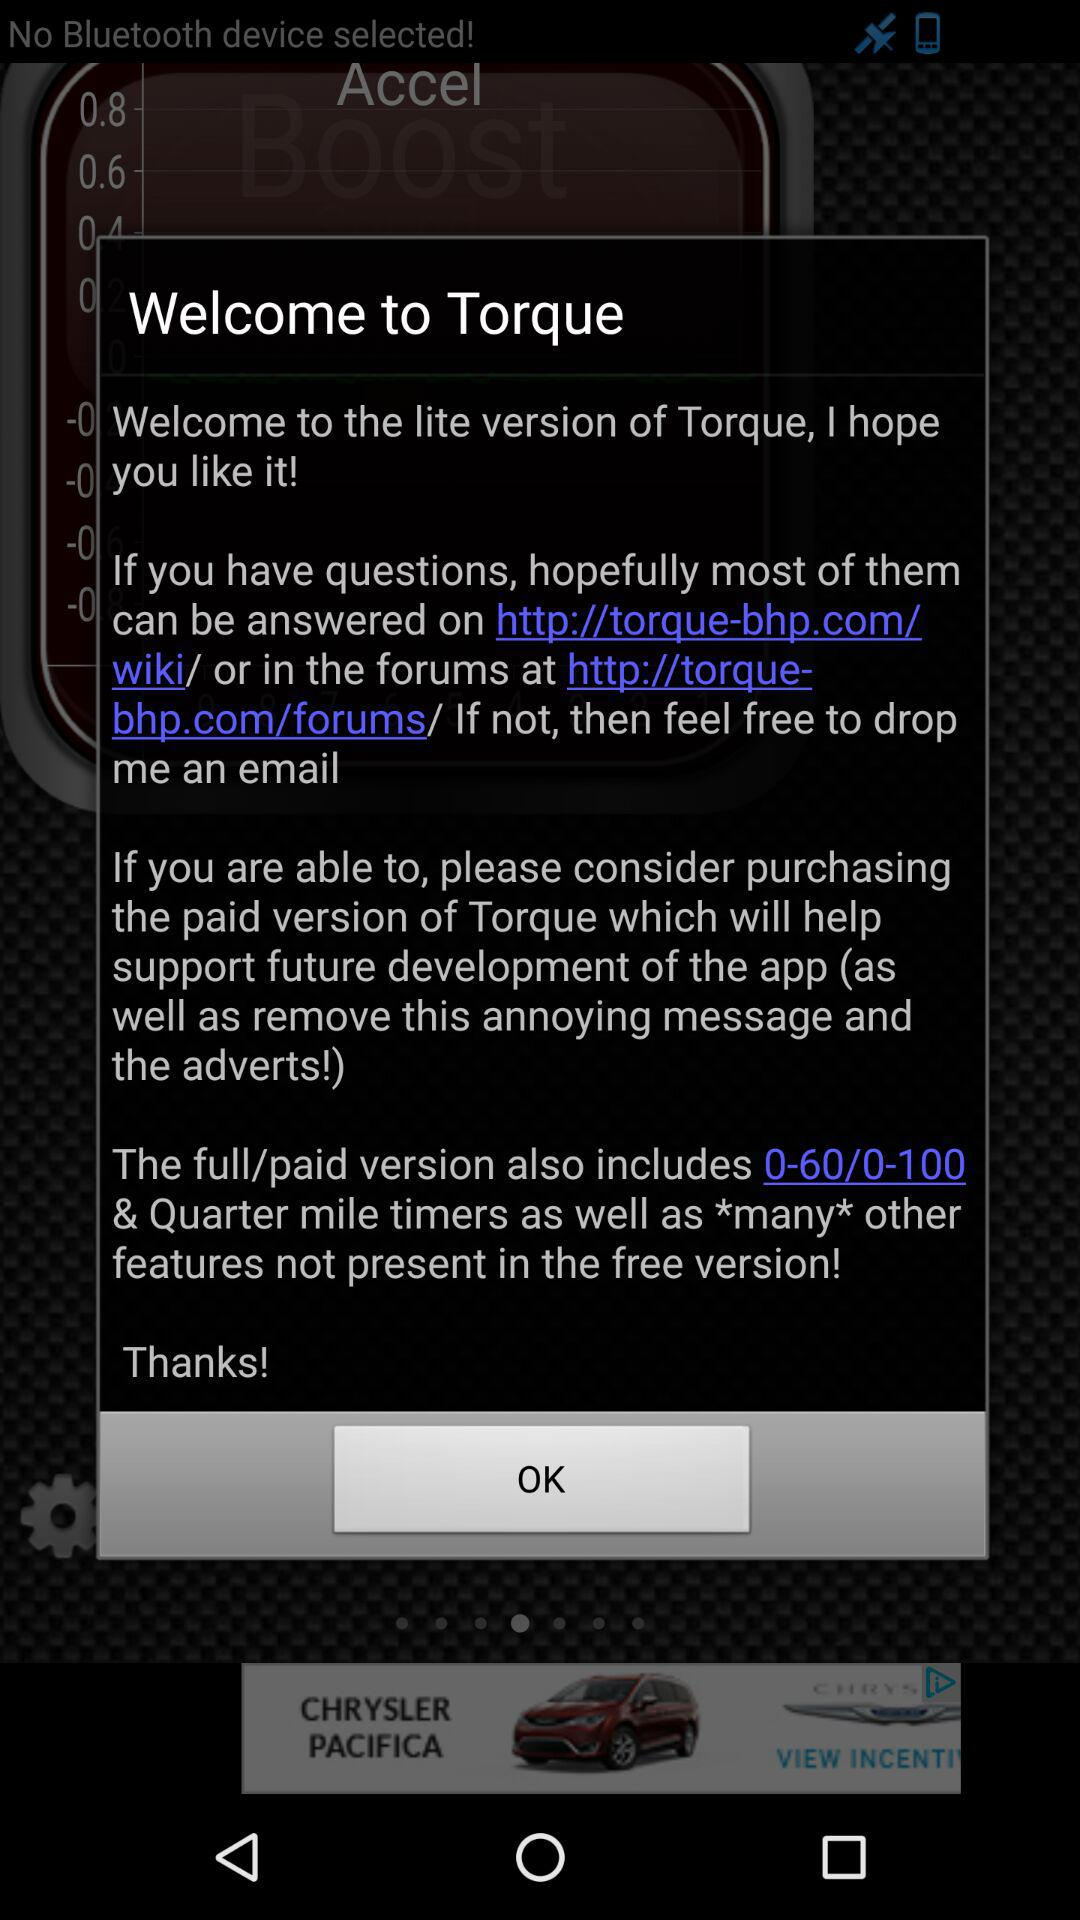What is the application name? The application name is "Torque". 